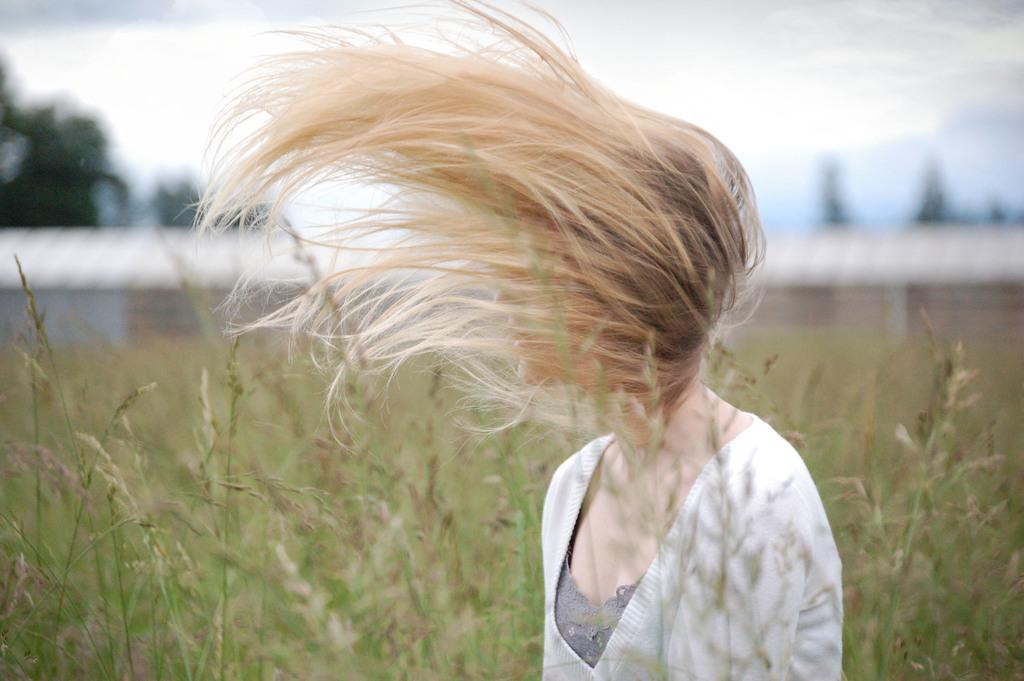Who is the main subject in the image? There is a girl in the image. What is a notable feature of the girl's appearance? The girl has blond hair. Where is the girl positioned in the image? The girl is standing in the middle of the image. What can be seen in the background of the image? There are plants visible in the background of the image. What is visible at the top of the image? The sky is visible in the image, and clouds are present in the sky. How many cakes are being served on the ice in the image? There are no cakes or ice present in the image; it features a girl with blond hair standing in the middle of the image. What type of ice is visible in the image? There is no ice visible in the image. 